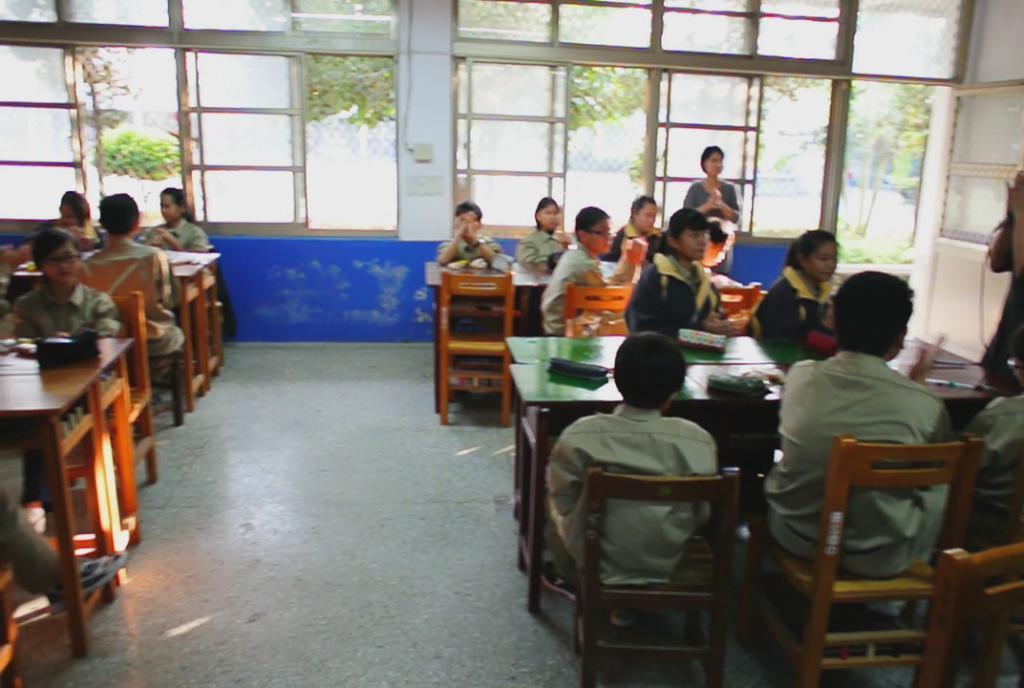Please provide a concise description of this image. In this image i can see a number of children sitting in the chairs in front of the table, and on the table i can see some objects, and in the background i can see windows through which i can see trees and a woman standing. 